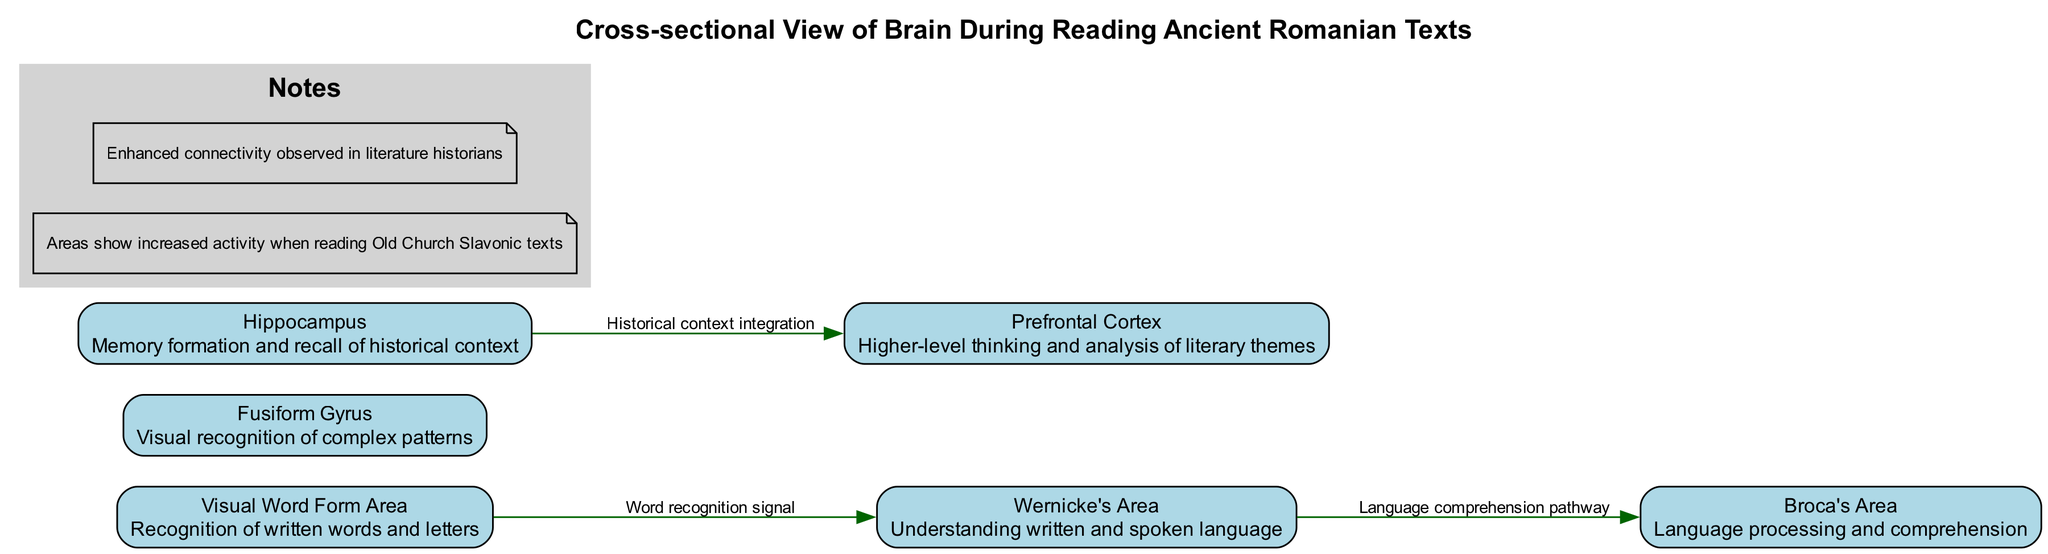What are the highlighted areas in the diagram? The highlighted areas are Broca's Area, Wernicke's Area, Visual Word Form Area, Fusiform Gyrus, Hippocampus, and Prefrontal Cortex.
Answer: Broca's Area, Wernicke's Area, Visual Word Form Area, Fusiform Gyrus, Hippocampus, Prefrontal Cortex Which area is responsible for memory formation and recall? In the diagram, the Hippocampus is labeled as responsible for memory formation and recall of historical context.
Answer: Hippocampus How many connections are shown in the diagram? The diagram displays three connections: from the Visual Word Form Area to Wernicke's Area, from Wernicke's Area to Broca's Area, and from the Hippocampus to the Prefrontal Cortex.
Answer: 3 What is the function of the Prefrontal Cortex? According to the diagram, the function of the Prefrontal Cortex involves higher-level thinking and analysis of literary themes.
Answer: Higher-level thinking and analysis of literary themes What do the connections between the highlighted areas indicate? The connections indicate pathways of information flow, such as word recognition signaling from the Visual Word Form Area to Wernicke’s Area and comprehension pathways leading to Broca’s Area.
Answer: Pathways of information flow How does the Hippocampus contribute to reading ancient Romanian texts? The diagram shows that the Hippocampus integrates historical context into the analysis, connecting with the Prefrontal Cortex to enhance understanding.
Answer: Integrates historical context What is the role of the Visual Word Form Area? In the diagram, the Visual Word Form Area is identified as responsible for the recognition of written words and letters.
Answer: Recognition of written words and letters Which area connects to the Prefrontal Cortex, and what is the nature of this connection? The Hippocampus connects to the Prefrontal Cortex, and this connection is labeled as "Historical context integration."
Answer: Historical context integration What does the note about increased activity when reading Old Church Slavonic texts imply? This note suggests that all highlighted areas demonstrate heightened brain activity during the reading of Old Church Slavonic texts, indicating their importance in this cognitive process.
Answer: Increased brain activity 